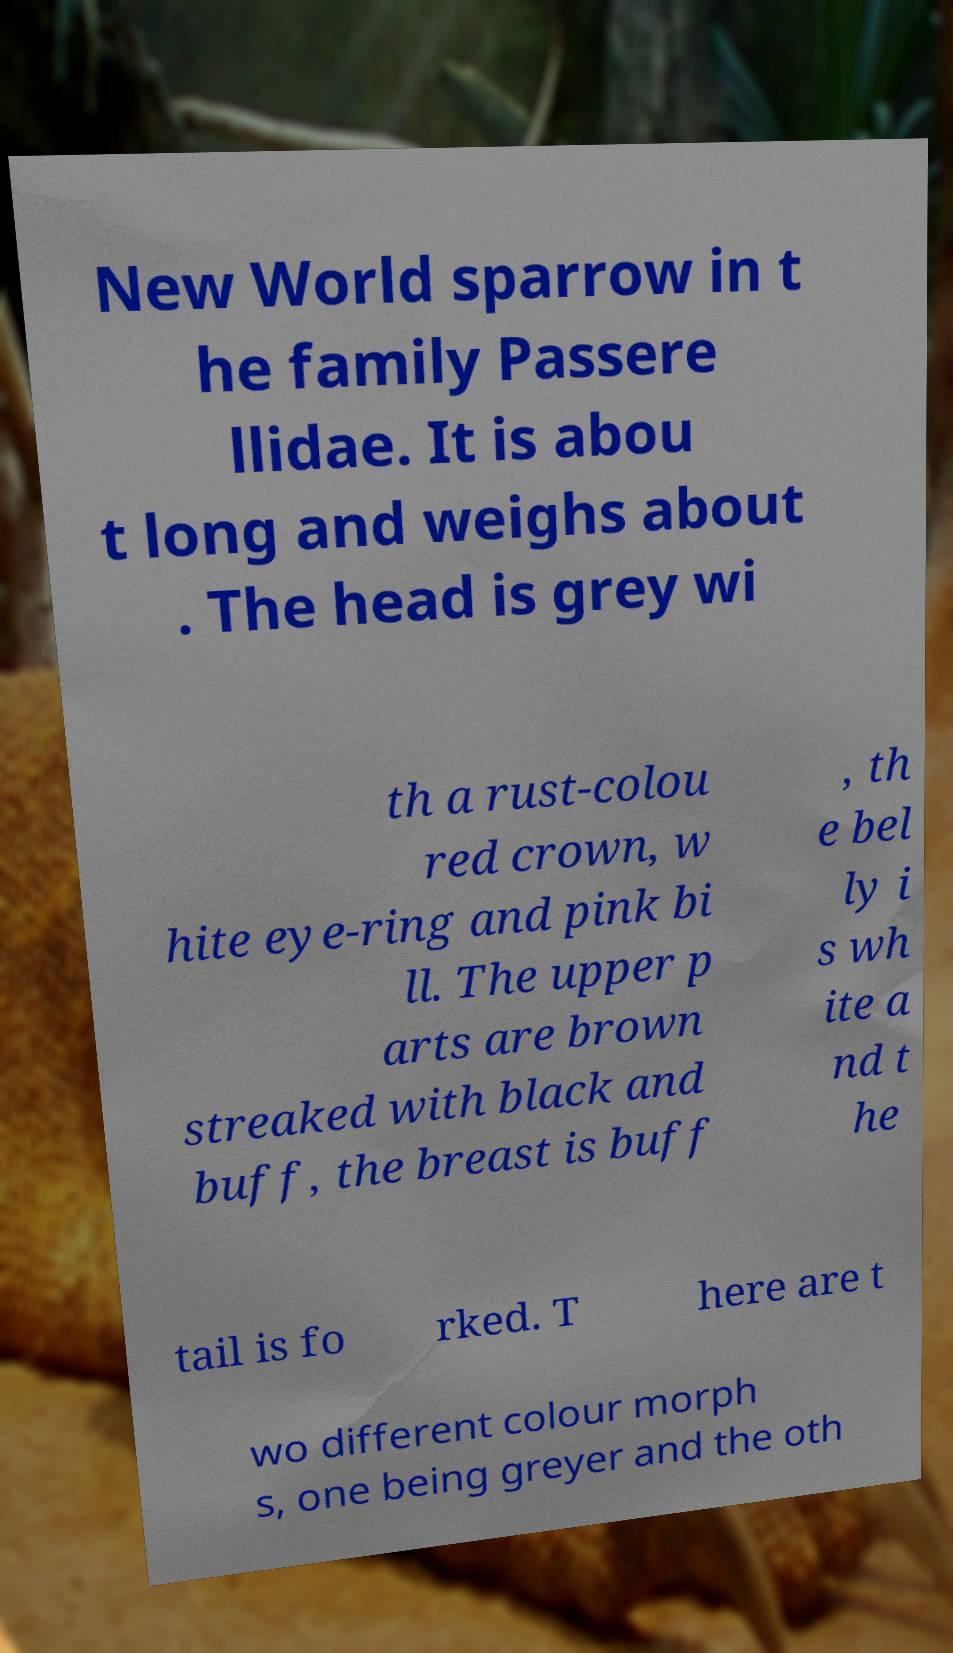Could you assist in decoding the text presented in this image and type it out clearly? New World sparrow in t he family Passere llidae. It is abou t long and weighs about . The head is grey wi th a rust-colou red crown, w hite eye-ring and pink bi ll. The upper p arts are brown streaked with black and buff, the breast is buff , th e bel ly i s wh ite a nd t he tail is fo rked. T here are t wo different colour morph s, one being greyer and the oth 